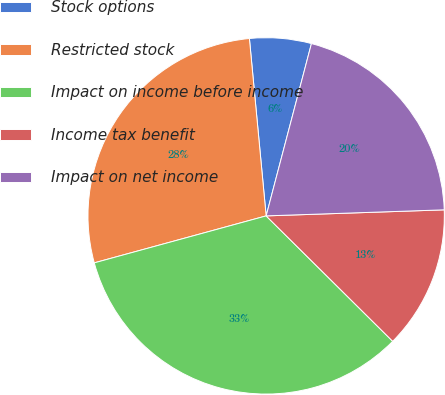<chart> <loc_0><loc_0><loc_500><loc_500><pie_chart><fcel>Stock options<fcel>Restricted stock<fcel>Impact on income before income<fcel>Income tax benefit<fcel>Impact on net income<nl><fcel>5.59%<fcel>27.75%<fcel>33.33%<fcel>12.97%<fcel>20.37%<nl></chart> 